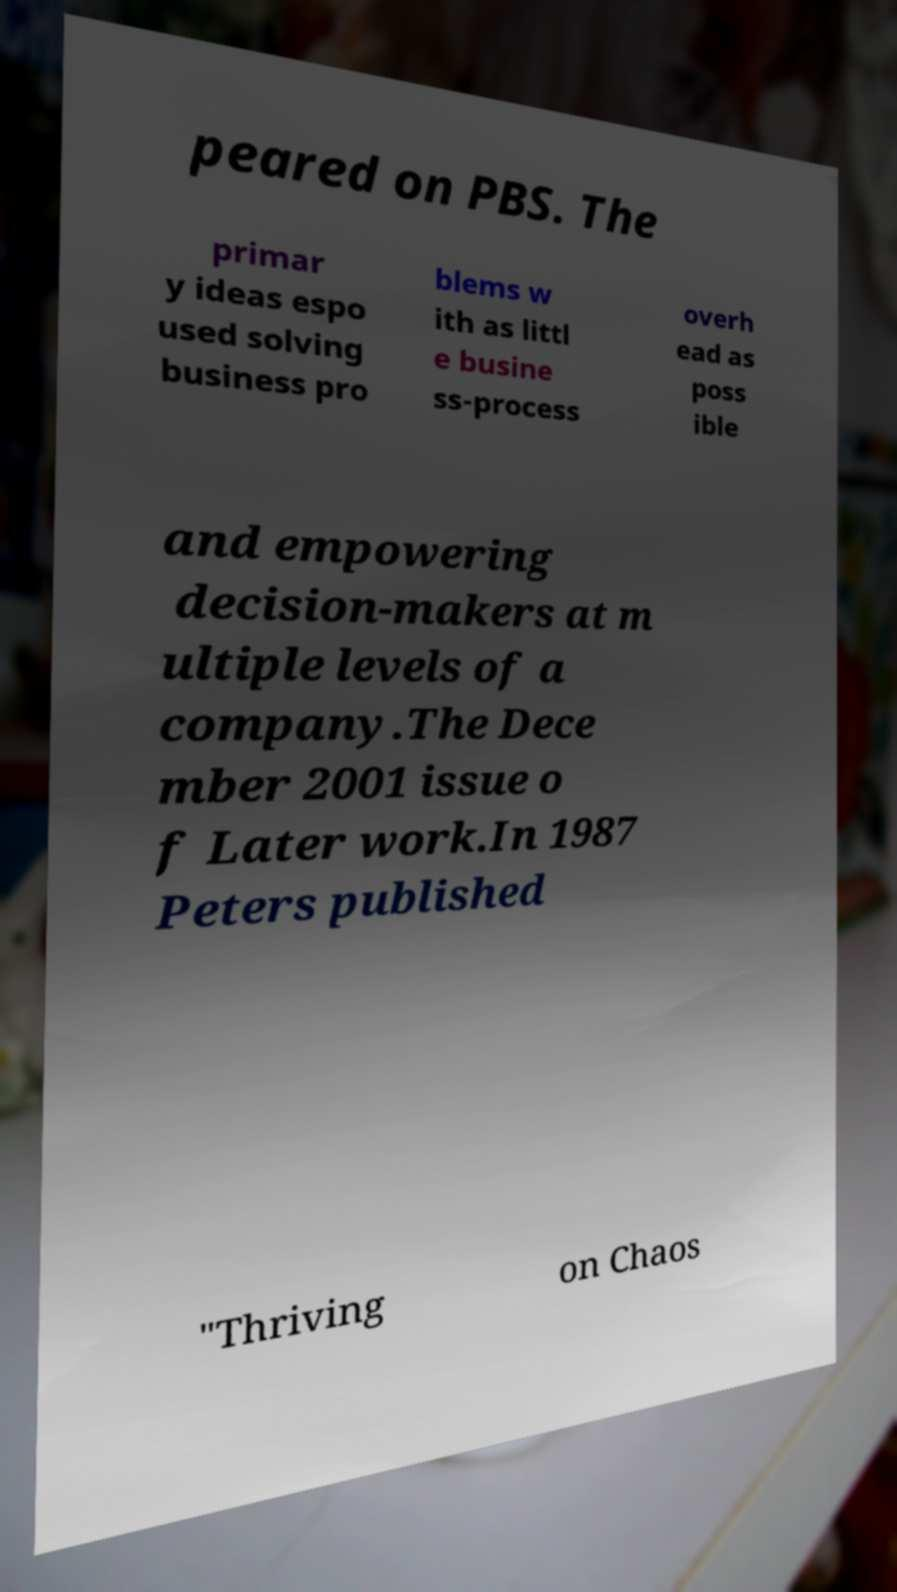I need the written content from this picture converted into text. Can you do that? peared on PBS. The primar y ideas espo used solving business pro blems w ith as littl e busine ss-process overh ead as poss ible and empowering decision-makers at m ultiple levels of a company.The Dece mber 2001 issue o f Later work.In 1987 Peters published "Thriving on Chaos 